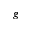Convert formula to latex. <formula><loc_0><loc_0><loc_500><loc_500>\boldsymbol g</formula> 